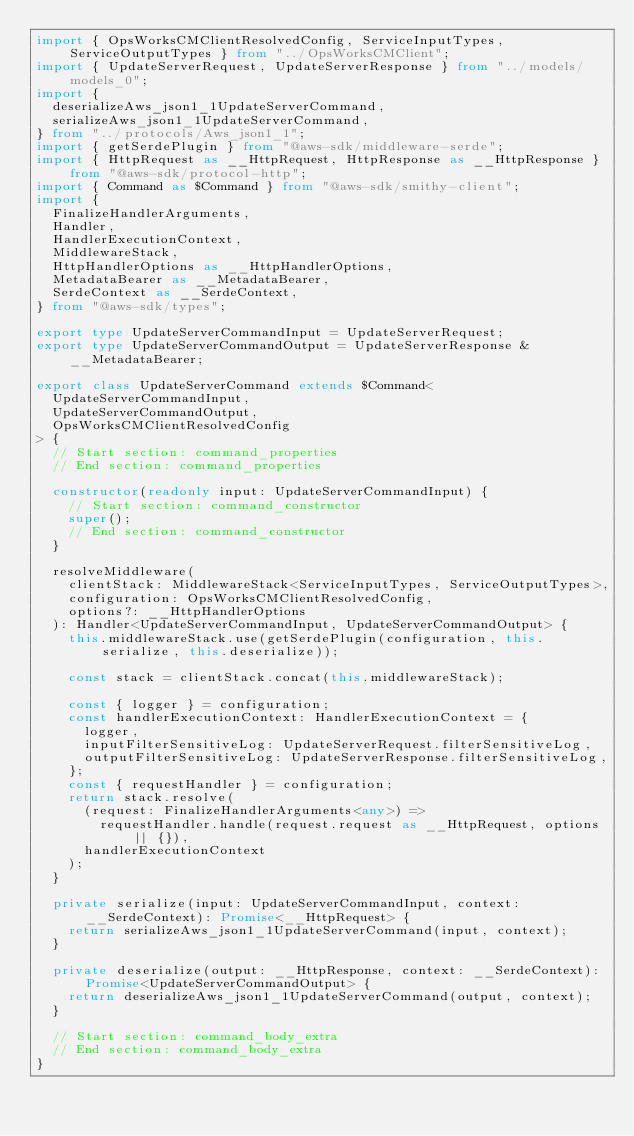Convert code to text. <code><loc_0><loc_0><loc_500><loc_500><_TypeScript_>import { OpsWorksCMClientResolvedConfig, ServiceInputTypes, ServiceOutputTypes } from "../OpsWorksCMClient";
import { UpdateServerRequest, UpdateServerResponse } from "../models/models_0";
import {
  deserializeAws_json1_1UpdateServerCommand,
  serializeAws_json1_1UpdateServerCommand,
} from "../protocols/Aws_json1_1";
import { getSerdePlugin } from "@aws-sdk/middleware-serde";
import { HttpRequest as __HttpRequest, HttpResponse as __HttpResponse } from "@aws-sdk/protocol-http";
import { Command as $Command } from "@aws-sdk/smithy-client";
import {
  FinalizeHandlerArguments,
  Handler,
  HandlerExecutionContext,
  MiddlewareStack,
  HttpHandlerOptions as __HttpHandlerOptions,
  MetadataBearer as __MetadataBearer,
  SerdeContext as __SerdeContext,
} from "@aws-sdk/types";

export type UpdateServerCommandInput = UpdateServerRequest;
export type UpdateServerCommandOutput = UpdateServerResponse & __MetadataBearer;

export class UpdateServerCommand extends $Command<
  UpdateServerCommandInput,
  UpdateServerCommandOutput,
  OpsWorksCMClientResolvedConfig
> {
  // Start section: command_properties
  // End section: command_properties

  constructor(readonly input: UpdateServerCommandInput) {
    // Start section: command_constructor
    super();
    // End section: command_constructor
  }

  resolveMiddleware(
    clientStack: MiddlewareStack<ServiceInputTypes, ServiceOutputTypes>,
    configuration: OpsWorksCMClientResolvedConfig,
    options?: __HttpHandlerOptions
  ): Handler<UpdateServerCommandInput, UpdateServerCommandOutput> {
    this.middlewareStack.use(getSerdePlugin(configuration, this.serialize, this.deserialize));

    const stack = clientStack.concat(this.middlewareStack);

    const { logger } = configuration;
    const handlerExecutionContext: HandlerExecutionContext = {
      logger,
      inputFilterSensitiveLog: UpdateServerRequest.filterSensitiveLog,
      outputFilterSensitiveLog: UpdateServerResponse.filterSensitiveLog,
    };
    const { requestHandler } = configuration;
    return stack.resolve(
      (request: FinalizeHandlerArguments<any>) =>
        requestHandler.handle(request.request as __HttpRequest, options || {}),
      handlerExecutionContext
    );
  }

  private serialize(input: UpdateServerCommandInput, context: __SerdeContext): Promise<__HttpRequest> {
    return serializeAws_json1_1UpdateServerCommand(input, context);
  }

  private deserialize(output: __HttpResponse, context: __SerdeContext): Promise<UpdateServerCommandOutput> {
    return deserializeAws_json1_1UpdateServerCommand(output, context);
  }

  // Start section: command_body_extra
  // End section: command_body_extra
}
</code> 